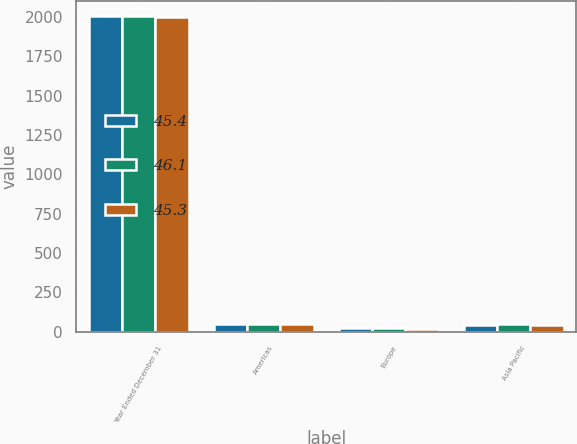Convert chart. <chart><loc_0><loc_0><loc_500><loc_500><stacked_bar_chart><ecel><fcel>Year Ended December 31<fcel>Americas<fcel>Europe<fcel>Asia Pacific<nl><fcel>45.4<fcel>2003<fcel>51.2<fcel>26.3<fcel>45.3<nl><fcel>46.1<fcel>2002<fcel>48.3<fcel>24.4<fcel>46.1<nl><fcel>45.3<fcel>2001<fcel>47.4<fcel>19.5<fcel>45.4<nl></chart> 